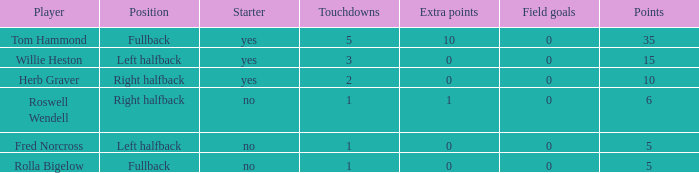For left halfback willie heston, what is the least number of touchdowns he has achieved when he has more than 15 points? None. 